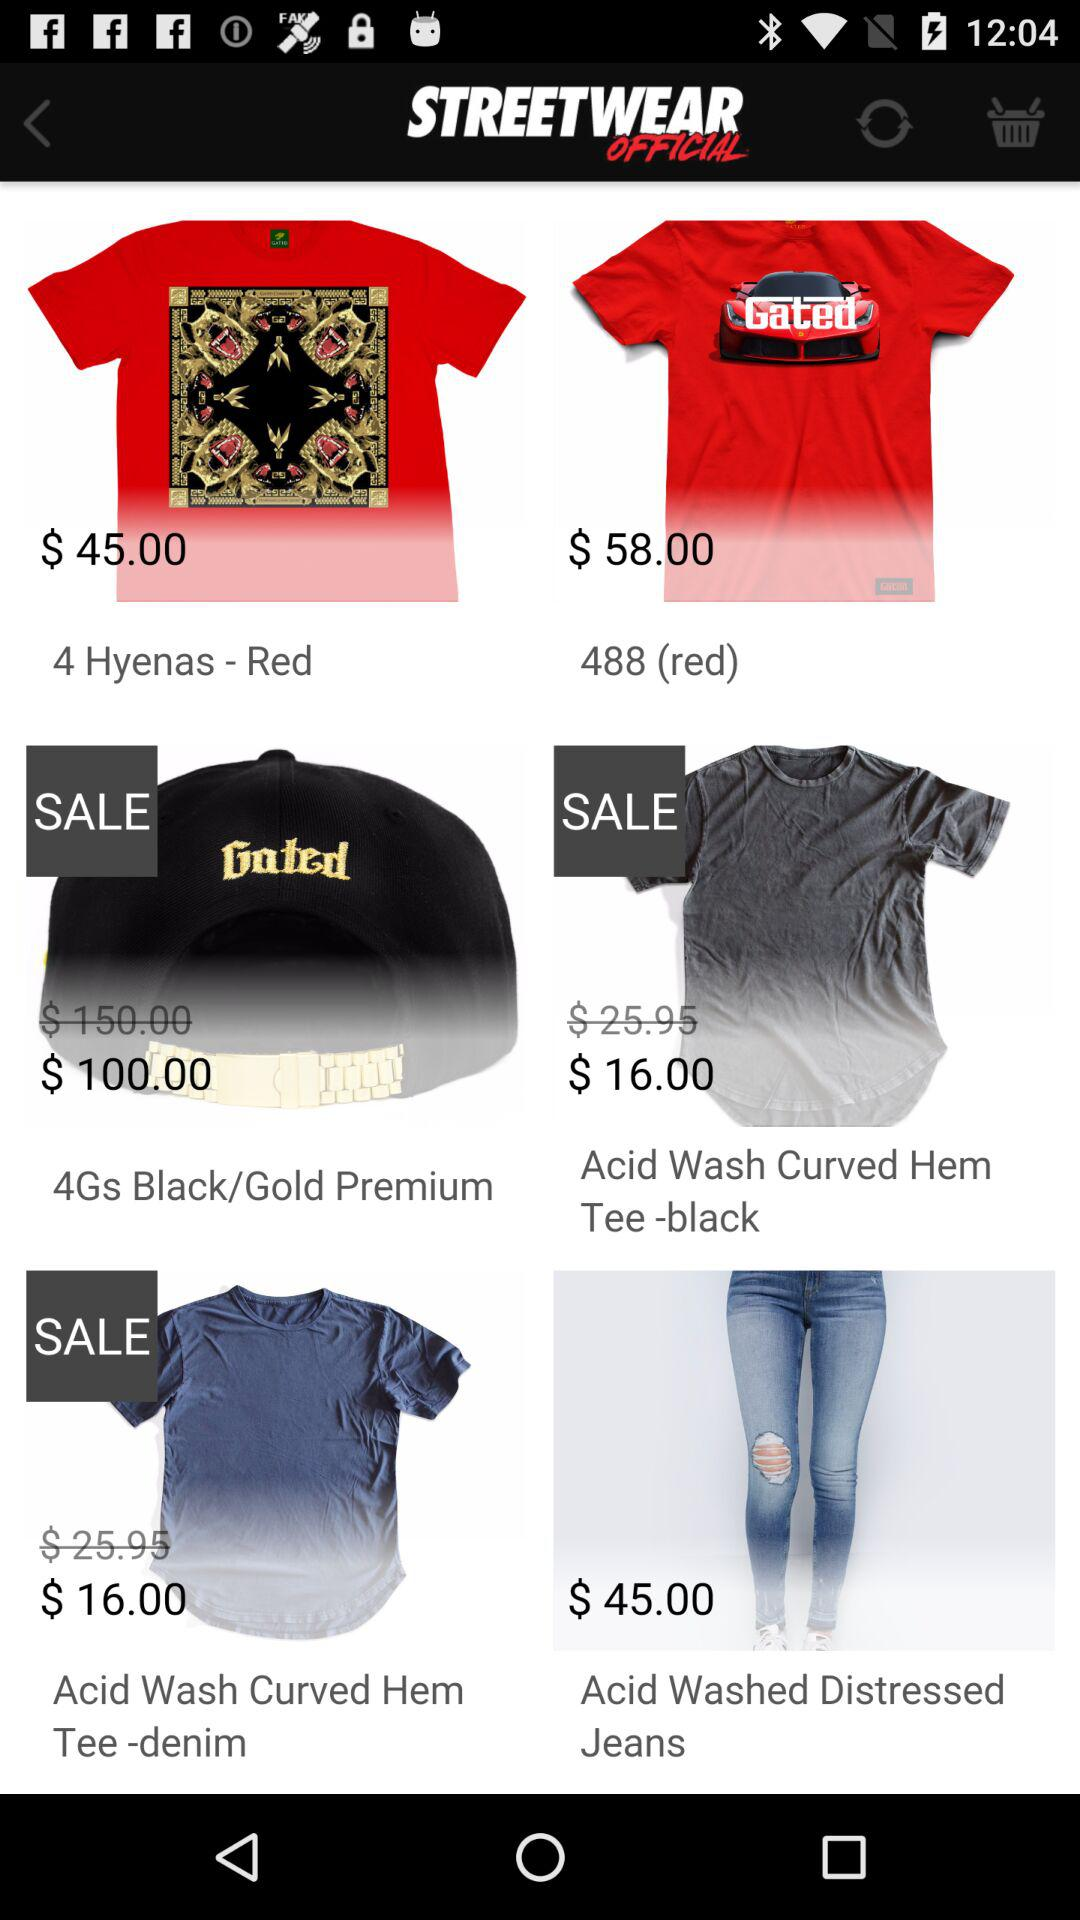How many items are on sale?
Answer the question using a single word or phrase. 3 